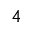Convert formula to latex. <formula><loc_0><loc_0><loc_500><loc_500>4</formula> 